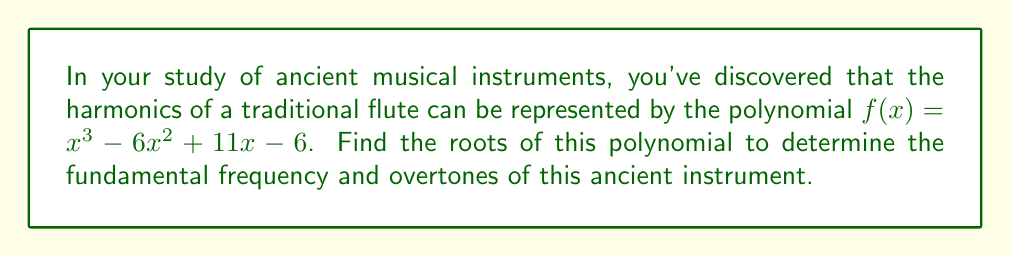Teach me how to tackle this problem. To find the roots of the polynomial $f(x) = x^3 - 6x^2 + 11x - 6$, we'll use factoring techniques:

1) First, let's check if there are any rational roots using the rational root theorem. The possible rational roots are the factors of the constant term (6): ±1, ±2, ±3, ±6.

2) Testing these values, we find that $f(1) = 0$. So $(x-1)$ is a factor.

3) We can use polynomial long division to divide $f(x)$ by $(x-1)$:

   $x^3 - 6x^2 + 11x - 6 = (x-1)(x^2 - 5x + 6)$

4) Now we need to factor the quadratic $x^2 - 5x + 6$:
   
   $x^2 - 5x + 6 = (x-2)(x-3)$

5) Therefore, the complete factorization is:

   $f(x) = (x-1)(x-2)(x-3)$

6) The roots of the polynomial are the values that make each factor equal to zero:

   $x = 1$, $x = 2$, and $x = 3$

These roots represent the fundamental frequency (x = 1) and the first two overtones (x = 2 and x = 3) of the ancient flute.
Answer: The roots of the polynomial are $x = 1$, $x = 2$, and $x = 3$. 